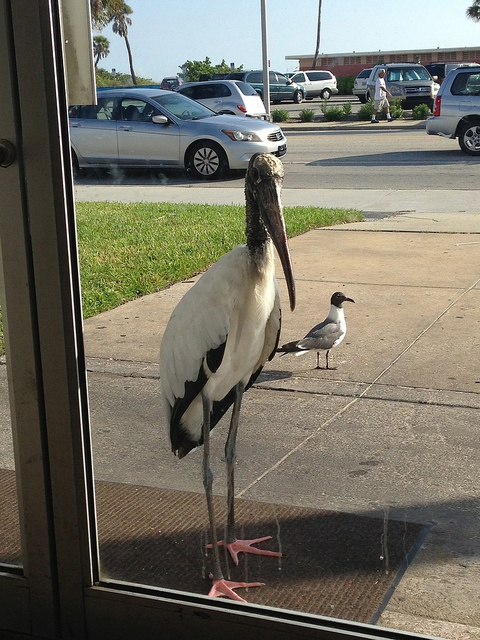Describe the objects in this image and their specific colors. I can see bird in black and gray tones, car in black and gray tones, car in black and gray tones, car in black, gray, blue, and darkblue tones, and car in black, gray, and white tones in this image. 